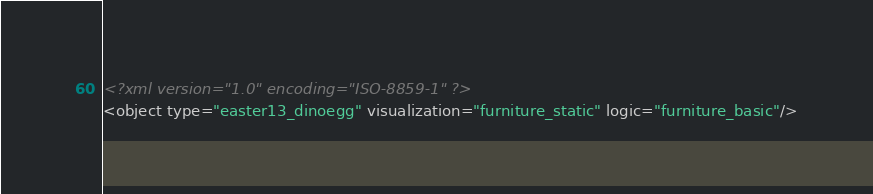Convert code to text. <code><loc_0><loc_0><loc_500><loc_500><_XML_><?xml version="1.0" encoding="ISO-8859-1" ?>
<object type="easter13_dinoegg" visualization="furniture_static" logic="furniture_basic"/></code> 